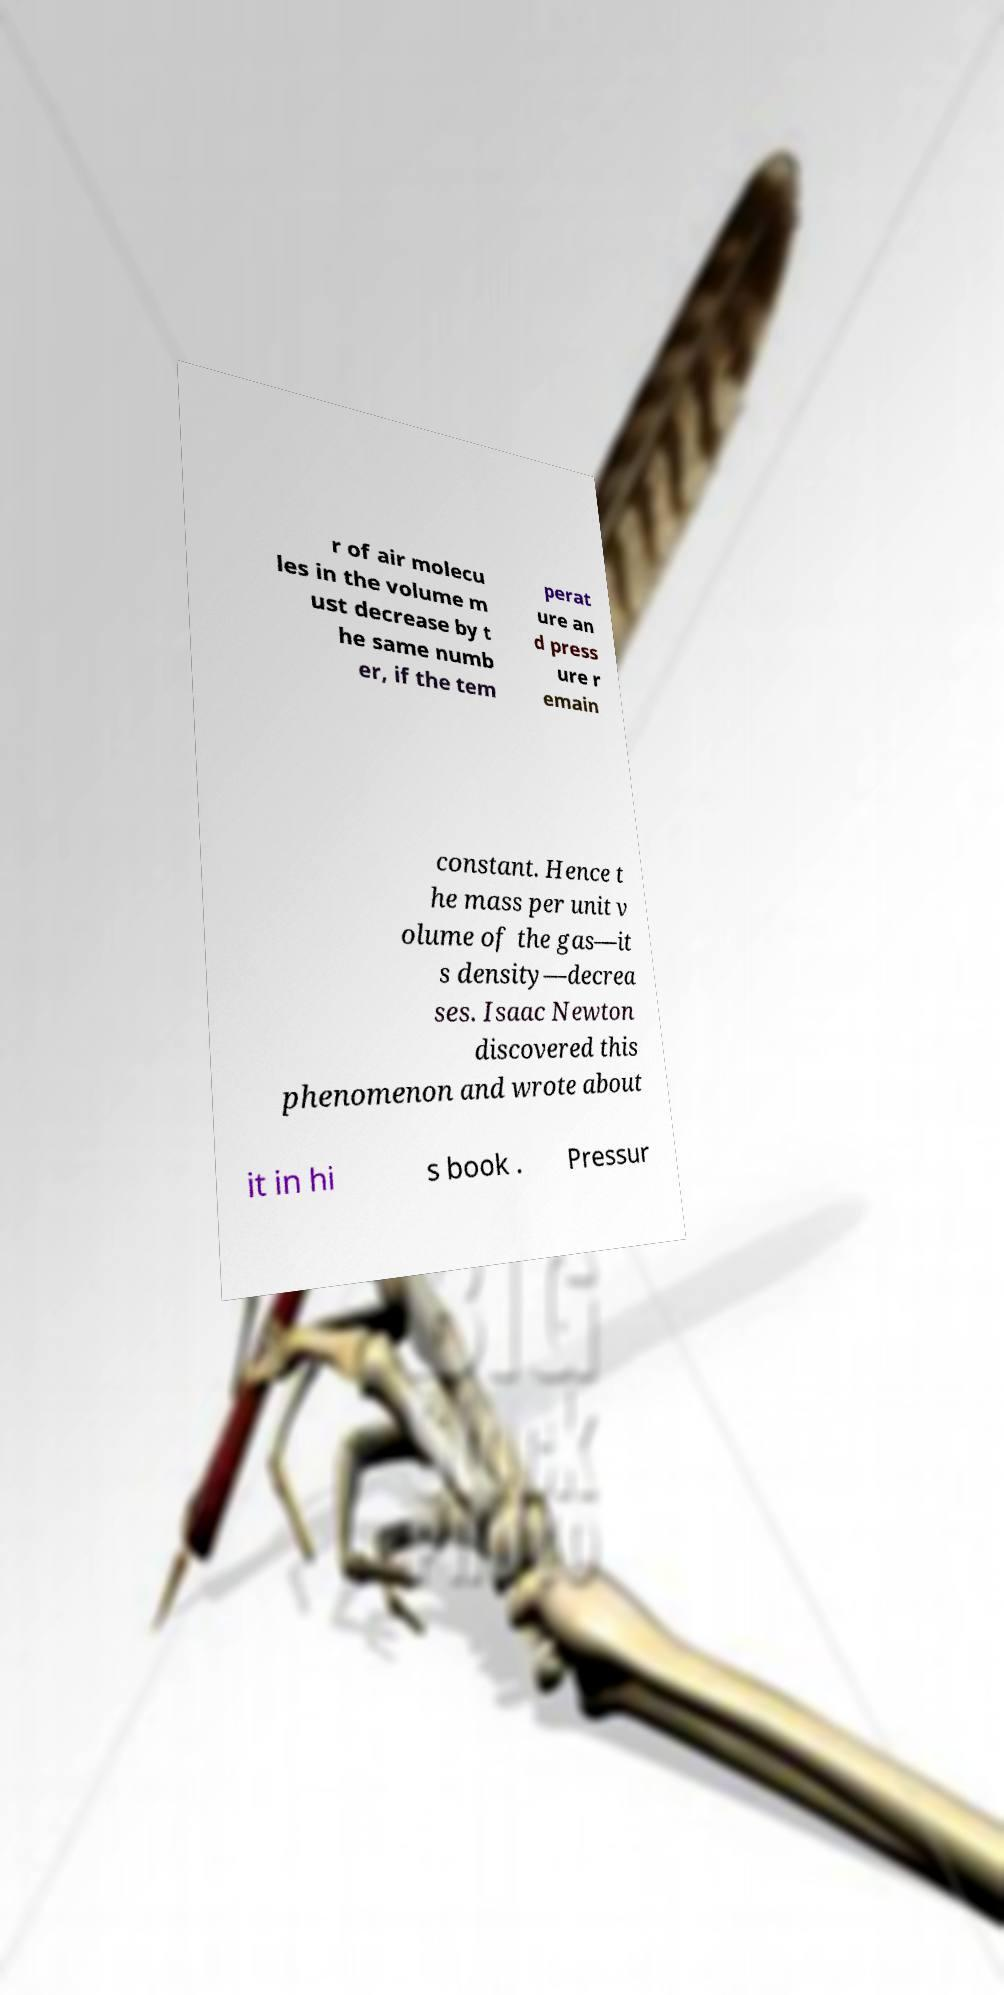There's text embedded in this image that I need extracted. Can you transcribe it verbatim? r of air molecu les in the volume m ust decrease by t he same numb er, if the tem perat ure an d press ure r emain constant. Hence t he mass per unit v olume of the gas—it s density—decrea ses. Isaac Newton discovered this phenomenon and wrote about it in hi s book . Pressur 